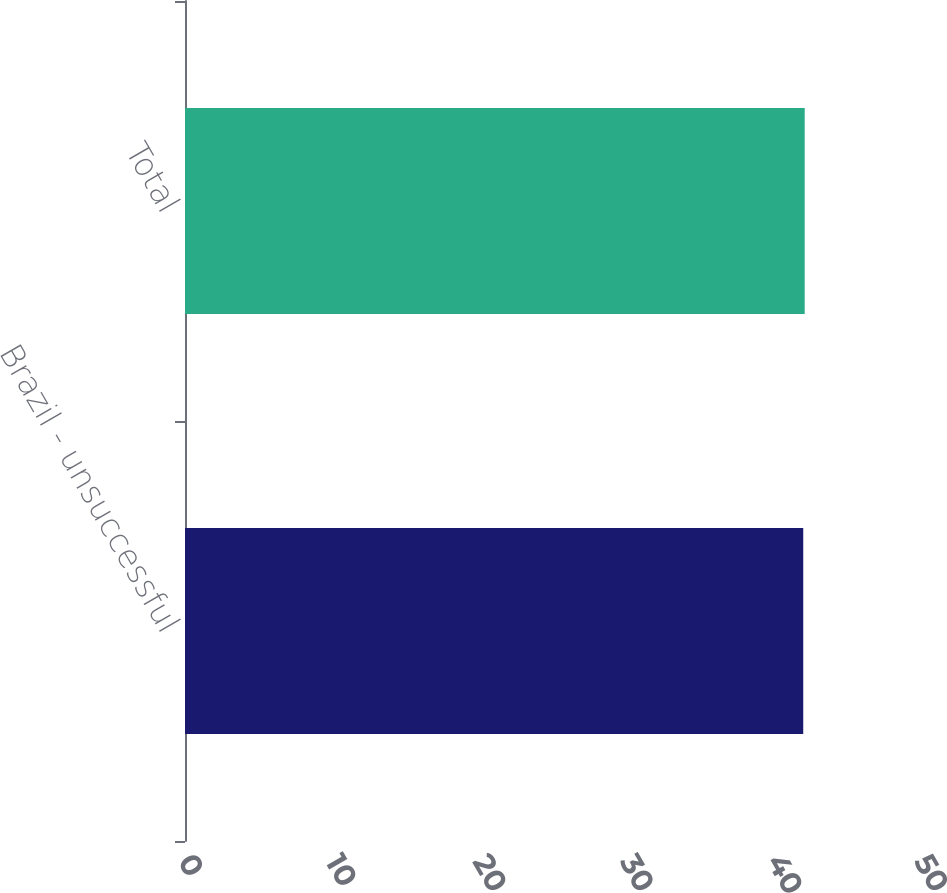Convert chart. <chart><loc_0><loc_0><loc_500><loc_500><bar_chart><fcel>Brazil - unsuccessful<fcel>Total<nl><fcel>42<fcel>42.1<nl></chart> 